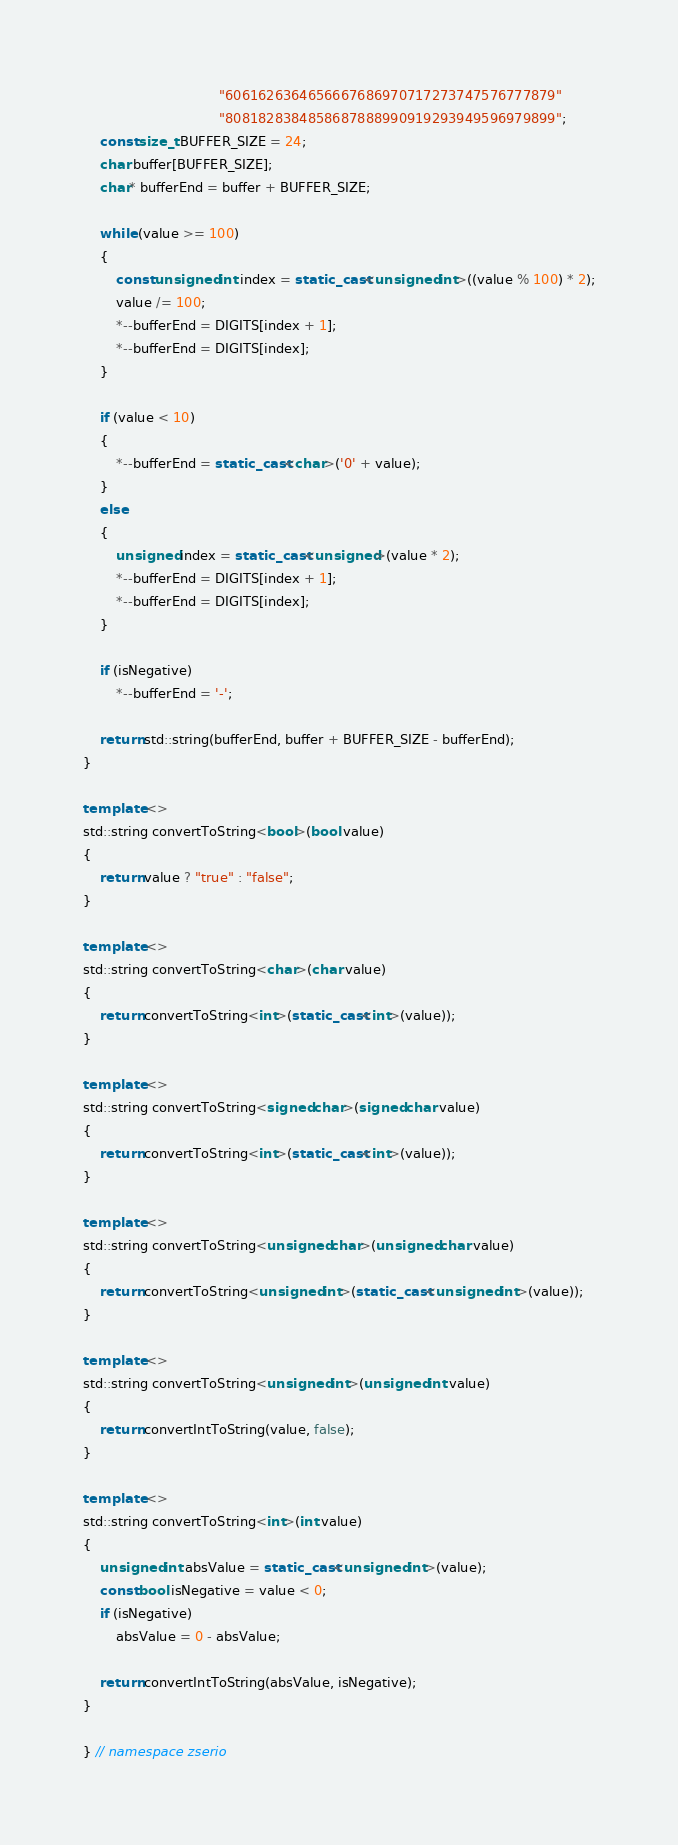<code> <loc_0><loc_0><loc_500><loc_500><_C++_>                                 "6061626364656667686970717273747576777879"
                                 "8081828384858687888990919293949596979899";
    const size_t BUFFER_SIZE = 24;
    char buffer[BUFFER_SIZE];
    char* bufferEnd = buffer + BUFFER_SIZE;

    while (value >= 100)
    {
        const unsigned int index = static_cast<unsigned int>((value % 100) * 2);
        value /= 100;
        *--bufferEnd = DIGITS[index + 1];
        *--bufferEnd = DIGITS[index];
    }

    if (value < 10)
    {
        *--bufferEnd = static_cast<char>('0' + value);
    }
    else
    {
        unsigned index = static_cast<unsigned>(value * 2);
        *--bufferEnd = DIGITS[index + 1];
        *--bufferEnd = DIGITS[index];
    }

    if (isNegative)
        *--bufferEnd = '-';

    return std::string(bufferEnd, buffer + BUFFER_SIZE - bufferEnd);
}

template <>
std::string convertToString<bool>(bool value)
{
    return value ? "true" : "false";
}

template <>
std::string convertToString<char>(char value)
{
    return convertToString<int>(static_cast<int>(value));
}

template <>
std::string convertToString<signed char>(signed char value)
{
    return convertToString<int>(static_cast<int>(value));
}

template <>
std::string convertToString<unsigned char>(unsigned char value)
{
    return convertToString<unsigned int>(static_cast<unsigned int>(value));
}

template <>
std::string convertToString<unsigned int>(unsigned int value)
{
    return convertIntToString(value, false);
}

template <>
std::string convertToString<int>(int value)
{
    unsigned int absValue = static_cast<unsigned int>(value);
    const bool isNegative = value < 0;
    if (isNegative)
        absValue = 0 - absValue;

    return convertIntToString(absValue, isNegative);
}

} // namespace zserio
</code> 